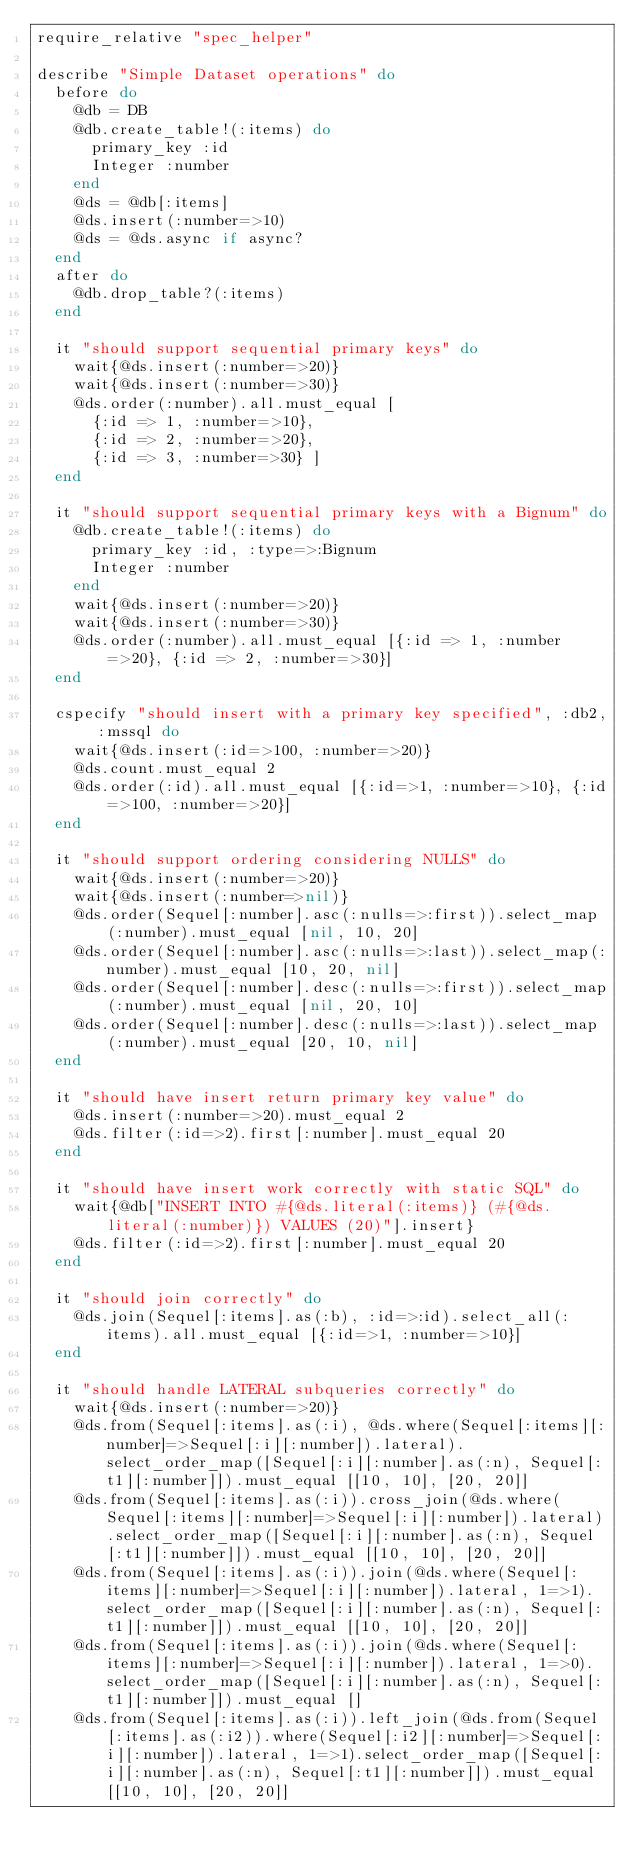<code> <loc_0><loc_0><loc_500><loc_500><_Ruby_>require_relative "spec_helper"

describe "Simple Dataset operations" do
  before do
    @db = DB
    @db.create_table!(:items) do
      primary_key :id
      Integer :number
    end
    @ds = @db[:items]
    @ds.insert(:number=>10)
    @ds = @ds.async if async?
  end
  after do
    @db.drop_table?(:items)
  end

  it "should support sequential primary keys" do
    wait{@ds.insert(:number=>20)}
    wait{@ds.insert(:number=>30)}
    @ds.order(:number).all.must_equal [
      {:id => 1, :number=>10},
      {:id => 2, :number=>20},
      {:id => 3, :number=>30} ]   
  end 

  it "should support sequential primary keys with a Bignum" do
    @db.create_table!(:items) do
      primary_key :id, :type=>:Bignum
      Integer :number
    end
    wait{@ds.insert(:number=>20)}
    wait{@ds.insert(:number=>30)}
    @ds.order(:number).all.must_equal [{:id => 1, :number=>20}, {:id => 2, :number=>30}]   
  end 

  cspecify "should insert with a primary key specified", :db2, :mssql do
    wait{@ds.insert(:id=>100, :number=>20)}
    @ds.count.must_equal 2
    @ds.order(:id).all.must_equal [{:id=>1, :number=>10}, {:id=>100, :number=>20}]
  end

  it "should support ordering considering NULLS" do
    wait{@ds.insert(:number=>20)}
    wait{@ds.insert(:number=>nil)}
    @ds.order(Sequel[:number].asc(:nulls=>:first)).select_map(:number).must_equal [nil, 10, 20]
    @ds.order(Sequel[:number].asc(:nulls=>:last)).select_map(:number).must_equal [10, 20, nil]
    @ds.order(Sequel[:number].desc(:nulls=>:first)).select_map(:number).must_equal [nil, 20, 10]
    @ds.order(Sequel[:number].desc(:nulls=>:last)).select_map(:number).must_equal [20, 10, nil]
  end

  it "should have insert return primary key value" do
    @ds.insert(:number=>20).must_equal 2
    @ds.filter(:id=>2).first[:number].must_equal 20
  end

  it "should have insert work correctly with static SQL" do
    wait{@db["INSERT INTO #{@ds.literal(:items)} (#{@ds.literal(:number)}) VALUES (20)"].insert}
    @ds.filter(:id=>2).first[:number].must_equal 20
  end

  it "should join correctly" do
    @ds.join(Sequel[:items].as(:b), :id=>:id).select_all(:items).all.must_equal [{:id=>1, :number=>10}]
  end

  it "should handle LATERAL subqueries correctly" do
    wait{@ds.insert(:number=>20)}
    @ds.from(Sequel[:items].as(:i), @ds.where(Sequel[:items][:number]=>Sequel[:i][:number]).lateral).select_order_map([Sequel[:i][:number].as(:n), Sequel[:t1][:number]]).must_equal [[10, 10], [20, 20]]
    @ds.from(Sequel[:items].as(:i)).cross_join(@ds.where(Sequel[:items][:number]=>Sequel[:i][:number]).lateral).select_order_map([Sequel[:i][:number].as(:n), Sequel[:t1][:number]]).must_equal [[10, 10], [20, 20]]
    @ds.from(Sequel[:items].as(:i)).join(@ds.where(Sequel[:items][:number]=>Sequel[:i][:number]).lateral, 1=>1).select_order_map([Sequel[:i][:number].as(:n), Sequel[:t1][:number]]).must_equal [[10, 10], [20, 20]]
    @ds.from(Sequel[:items].as(:i)).join(@ds.where(Sequel[:items][:number]=>Sequel[:i][:number]).lateral, 1=>0).select_order_map([Sequel[:i][:number].as(:n), Sequel[:t1][:number]]).must_equal []
    @ds.from(Sequel[:items].as(:i)).left_join(@ds.from(Sequel[:items].as(:i2)).where(Sequel[:i2][:number]=>Sequel[:i][:number]).lateral, 1=>1).select_order_map([Sequel[:i][:number].as(:n), Sequel[:t1][:number]]).must_equal [[10, 10], [20, 20]]</code> 